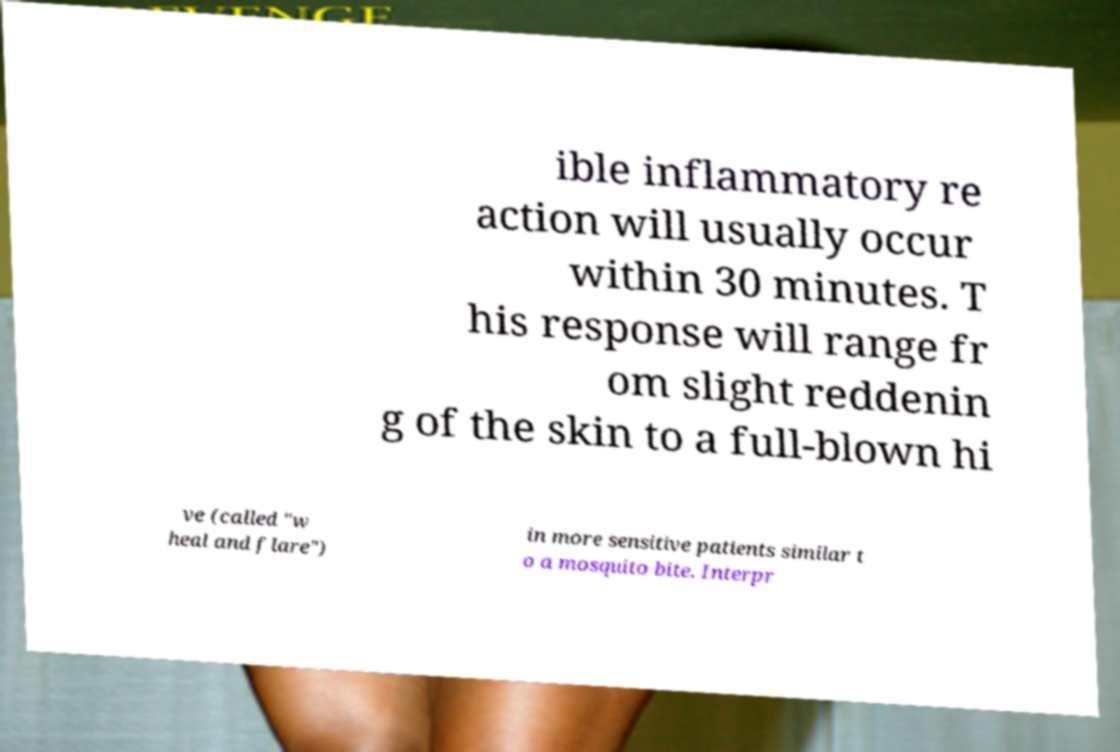Please identify and transcribe the text found in this image. ible inflammatory re action will usually occur within 30 minutes. T his response will range fr om slight reddenin g of the skin to a full-blown hi ve (called "w heal and flare") in more sensitive patients similar t o a mosquito bite. Interpr 